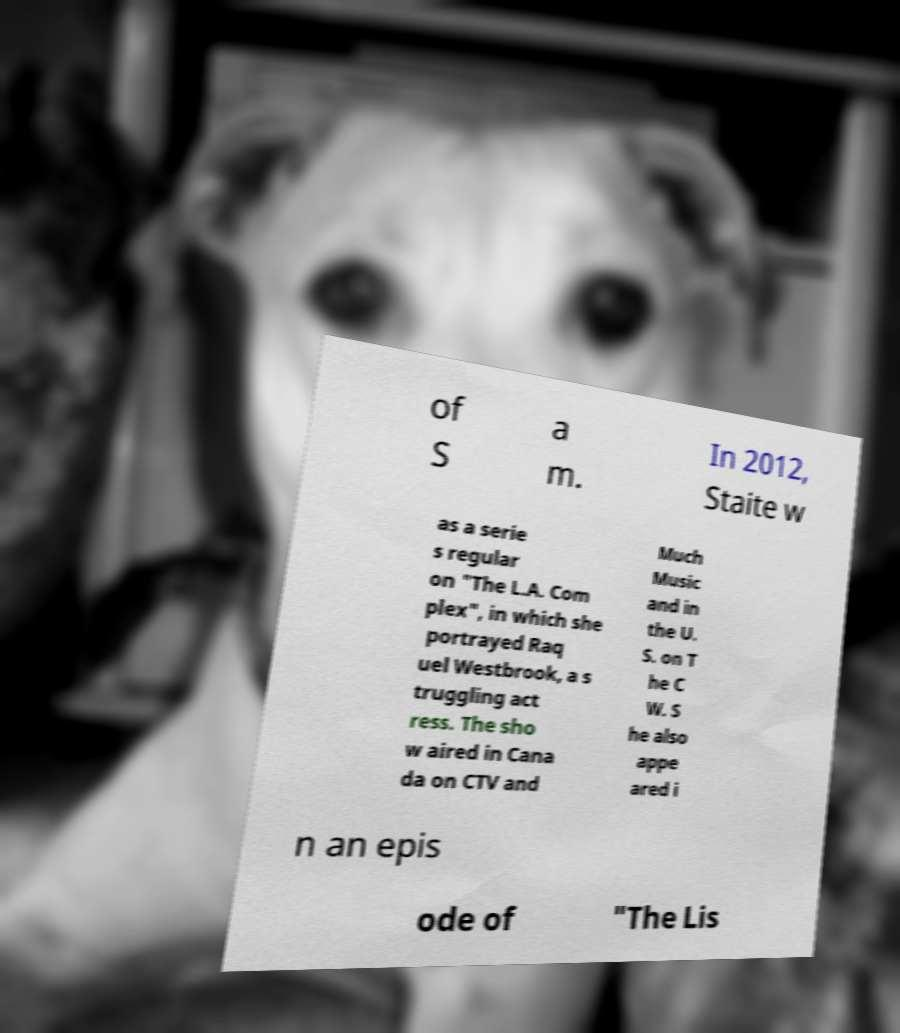Can you read and provide the text displayed in the image?This photo seems to have some interesting text. Can you extract and type it out for me? of S a m. In 2012, Staite w as a serie s regular on "The L.A. Com plex", in which she portrayed Raq uel Westbrook, a s truggling act ress. The sho w aired in Cana da on CTV and Much Music and in the U. S. on T he C W. S he also appe ared i n an epis ode of "The Lis 